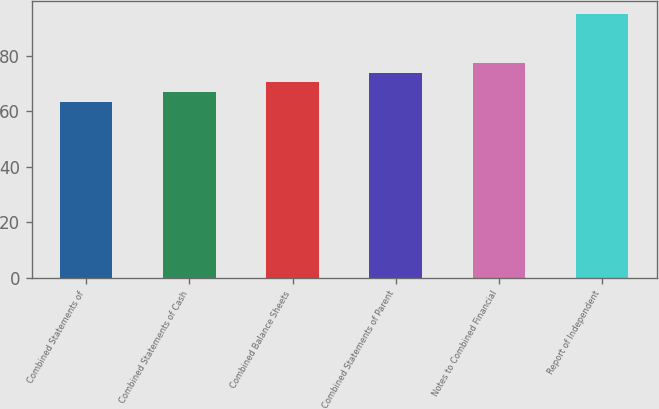Convert chart. <chart><loc_0><loc_0><loc_500><loc_500><bar_chart><fcel>Combined Statements of<fcel>Combined Statements of Cash<fcel>Combined Balance Sheets<fcel>Combined Statements of Parent<fcel>Notes to Combined Financial<fcel>Report of Independent<nl><fcel>63.5<fcel>67<fcel>70.5<fcel>74<fcel>77.5<fcel>95<nl></chart> 